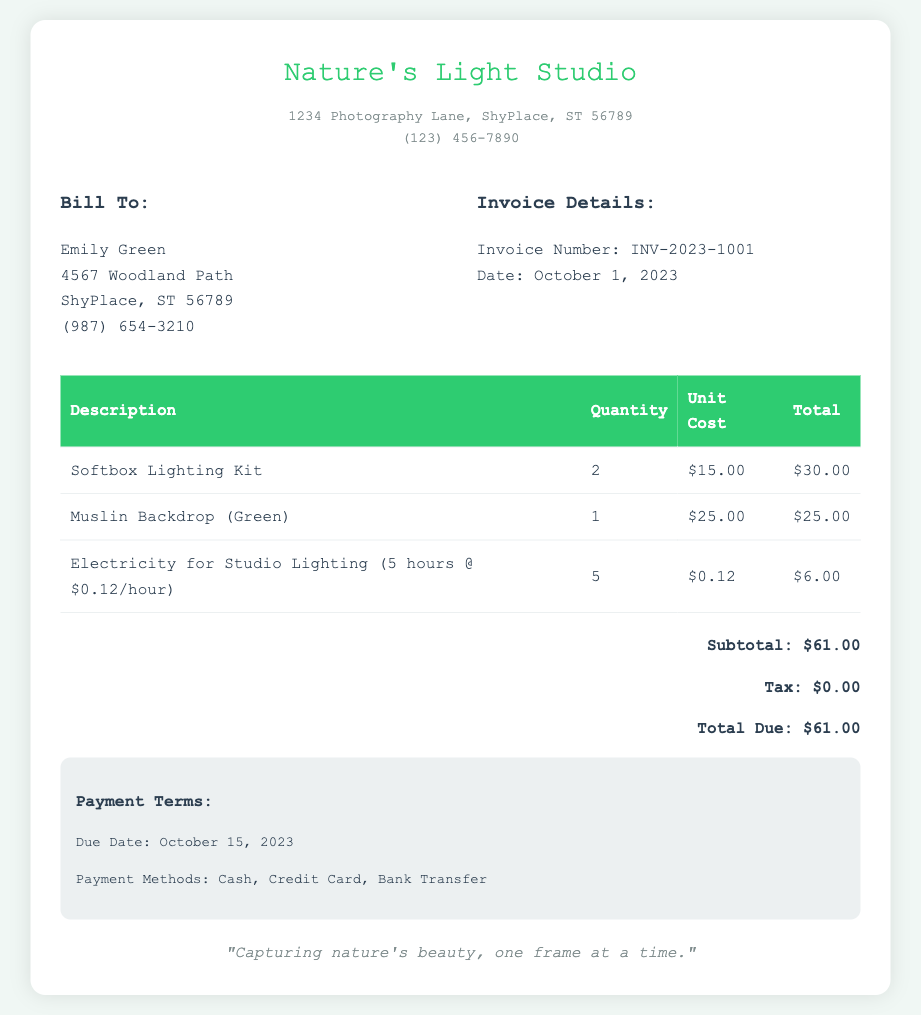What is the studio's name? The name of the studio, as listed in the document, is located at the top of the invoice.
Answer: Nature's Light Studio What is the invoice number? The invoice number is mentioned in the invoice details section of the document.
Answer: INV-2023-1001 How much is the total due? The total amount due is specified in the total section of the document.
Answer: $61.00 What is the quantity of softbox lighting kits? The quantity of softbox lighting kits is listed in the charges table under the item description.
Answer: 2 How much does electricity for studio lighting cost per hour? The cost of electricity per hour is detailed in the description of the electricity charge in the table.
Answer: $0.12 What is the payment due date? The due date for payment is found in the payment terms section of the document.
Answer: October 15, 2023 What is the subtotal of the items? The subtotal is provided in the total section right before the total due.
Answer: $61.00 How many muslin backdrops were charged? The number of muslin backdrops is indicated in the table under the quantity column for that item.
Answer: 1 What methods of payment are accepted? The payment methods are mentioned in the payment terms section of the invoice.
Answer: Cash, Credit Card, Bank Transfer 